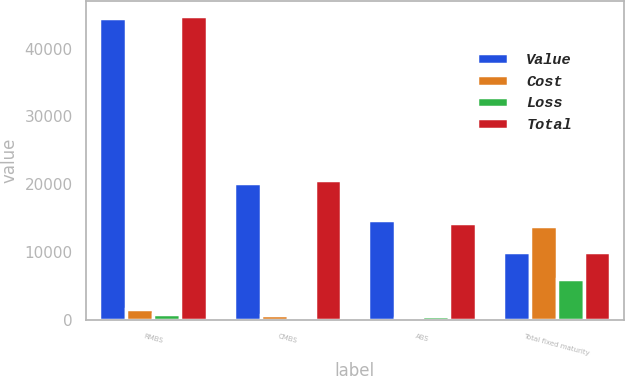Convert chart. <chart><loc_0><loc_0><loc_500><loc_500><stacked_bar_chart><ecel><fcel>RMBS<fcel>CMBS<fcel>ABS<fcel>Total fixed maturity<nl><fcel>Value<fcel>44468<fcel>20213<fcel>14725<fcel>9968.5<nl><fcel>Cost<fcel>1652<fcel>740<fcel>274<fcel>13907<nl><fcel>Loss<fcel>917<fcel>266<fcel>590<fcel>6030<nl><fcel>Total<fcel>44733<fcel>20675<fcel>14290<fcel>9968.5<nl></chart> 